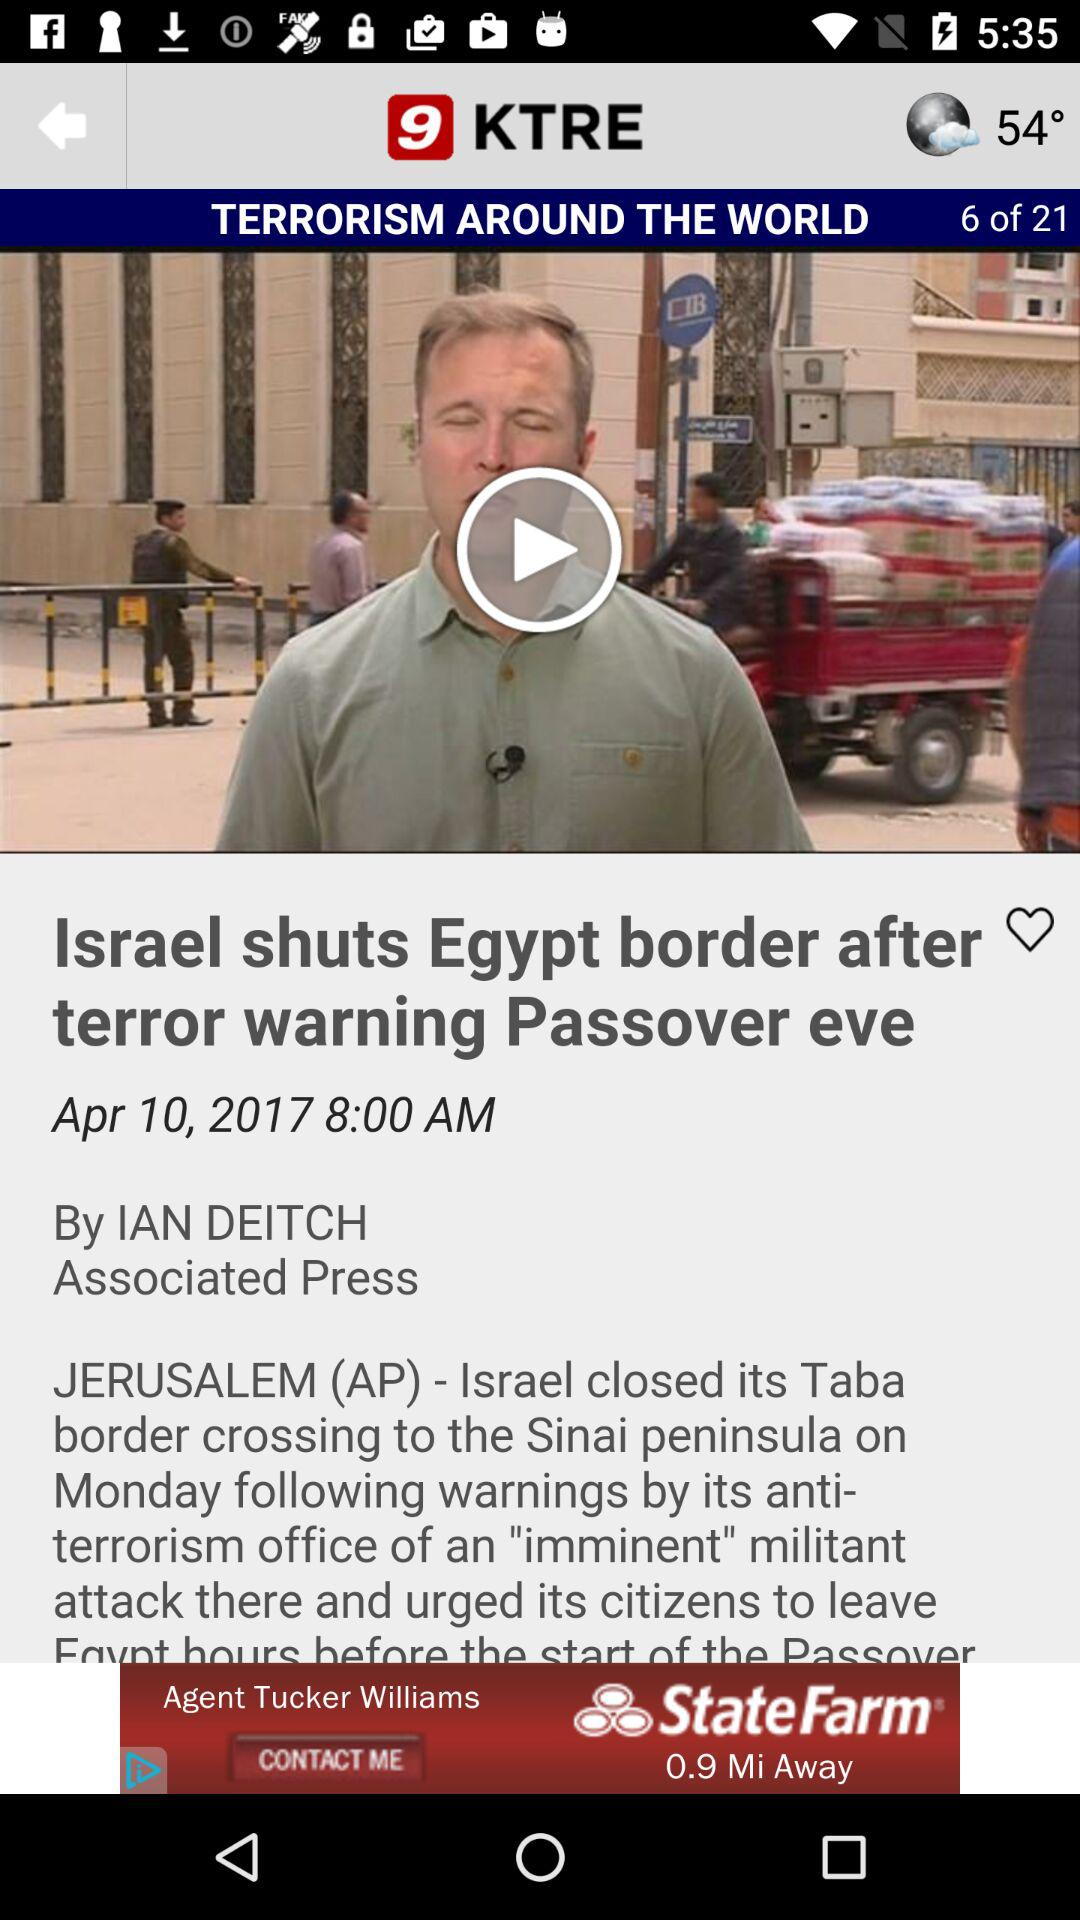What is the press name? The press name is "Associated Press". 